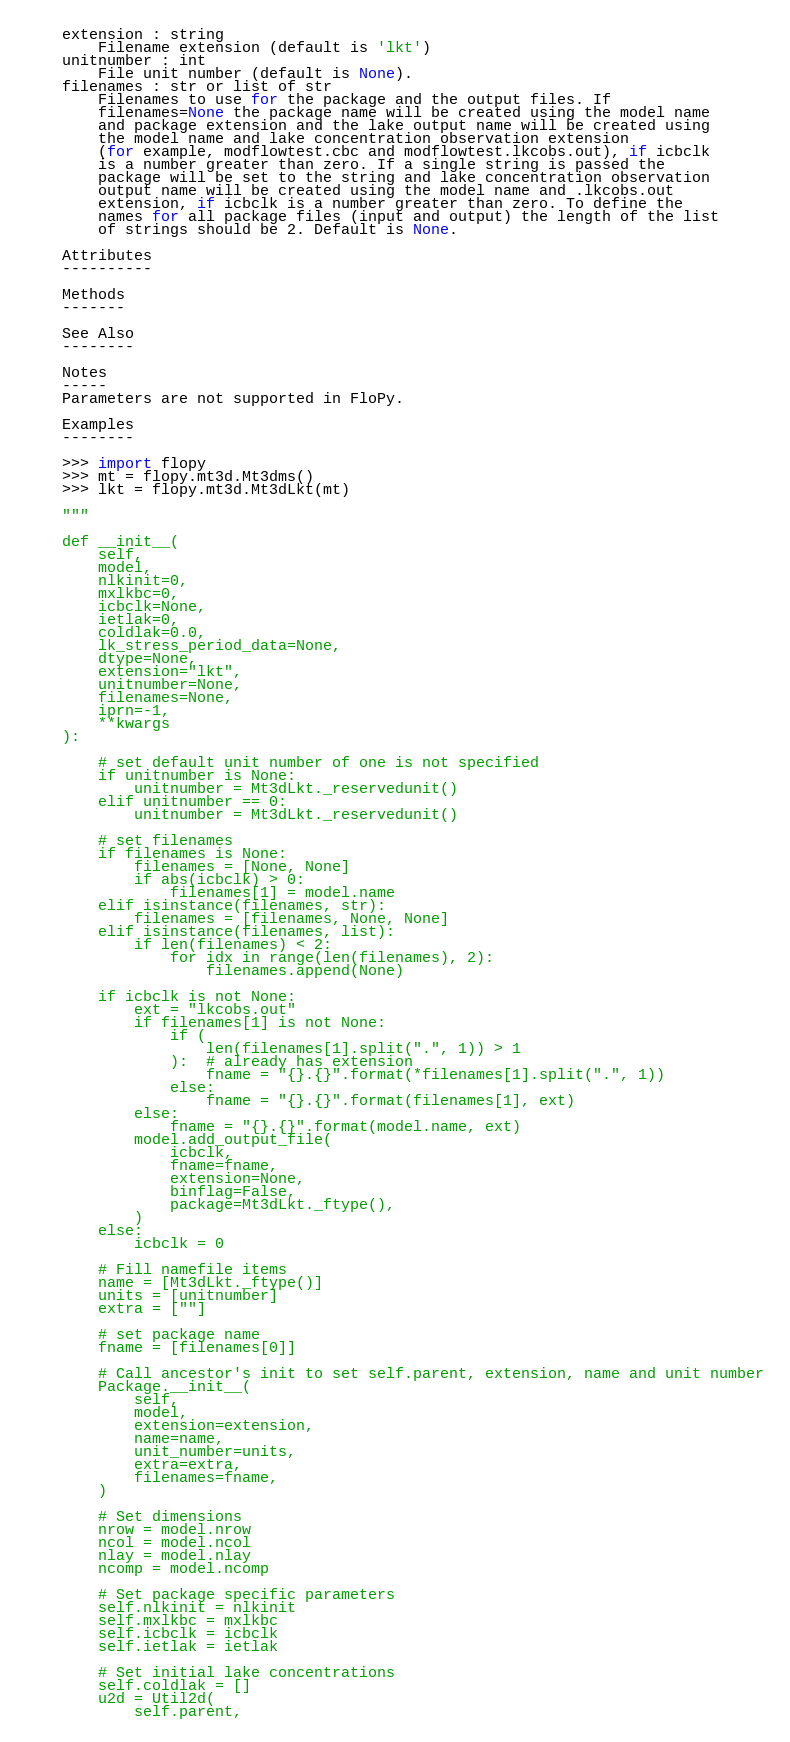<code> <loc_0><loc_0><loc_500><loc_500><_Python_>    extension : string
        Filename extension (default is 'lkt')
    unitnumber : int
        File unit number (default is None).
    filenames : str or list of str
        Filenames to use for the package and the output files. If
        filenames=None the package name will be created using the model name
        and package extension and the lake output name will be created using
        the model name and lake concentration observation extension
        (for example, modflowtest.cbc and modflowtest.lkcobs.out), if icbclk
        is a number greater than zero. If a single string is passed the
        package will be set to the string and lake concentration observation
        output name will be created using the model name and .lkcobs.out
        extension, if icbclk is a number greater than zero. To define the
        names for all package files (input and output) the length of the list
        of strings should be 2. Default is None.

    Attributes
    ----------

    Methods
    -------

    See Also
    --------

    Notes
    -----
    Parameters are not supported in FloPy.

    Examples
    --------

    >>> import flopy
    >>> mt = flopy.mt3d.Mt3dms()
    >>> lkt = flopy.mt3d.Mt3dLkt(mt)

    """

    def __init__(
        self,
        model,
        nlkinit=0,
        mxlkbc=0,
        icbclk=None,
        ietlak=0,
        coldlak=0.0,
        lk_stress_period_data=None,
        dtype=None,
        extension="lkt",
        unitnumber=None,
        filenames=None,
        iprn=-1,
        **kwargs
    ):

        # set default unit number of one is not specified
        if unitnumber is None:
            unitnumber = Mt3dLkt._reservedunit()
        elif unitnumber == 0:
            unitnumber = Mt3dLkt._reservedunit()

        # set filenames
        if filenames is None:
            filenames = [None, None]
            if abs(icbclk) > 0:
                filenames[1] = model.name
        elif isinstance(filenames, str):
            filenames = [filenames, None, None]
        elif isinstance(filenames, list):
            if len(filenames) < 2:
                for idx in range(len(filenames), 2):
                    filenames.append(None)

        if icbclk is not None:
            ext = "lkcobs.out"
            if filenames[1] is not None:
                if (
                    len(filenames[1].split(".", 1)) > 1
                ):  # already has extension
                    fname = "{}.{}".format(*filenames[1].split(".", 1))
                else:
                    fname = "{}.{}".format(filenames[1], ext)
            else:
                fname = "{}.{}".format(model.name, ext)
            model.add_output_file(
                icbclk,
                fname=fname,
                extension=None,
                binflag=False,
                package=Mt3dLkt._ftype(),
            )
        else:
            icbclk = 0

        # Fill namefile items
        name = [Mt3dLkt._ftype()]
        units = [unitnumber]
        extra = [""]

        # set package name
        fname = [filenames[0]]

        # Call ancestor's init to set self.parent, extension, name and unit number
        Package.__init__(
            self,
            model,
            extension=extension,
            name=name,
            unit_number=units,
            extra=extra,
            filenames=fname,
        )

        # Set dimensions
        nrow = model.nrow
        ncol = model.ncol
        nlay = model.nlay
        ncomp = model.ncomp

        # Set package specific parameters
        self.nlkinit = nlkinit
        self.mxlkbc = mxlkbc
        self.icbclk = icbclk
        self.ietlak = ietlak

        # Set initial lake concentrations
        self.coldlak = []
        u2d = Util2d(
            self.parent,</code> 